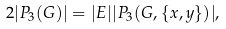<formula> <loc_0><loc_0><loc_500><loc_500>2 | P _ { 3 } ( G ) | = | E | | P _ { 3 } ( G , \{ x , y \} ) | ,</formula> 